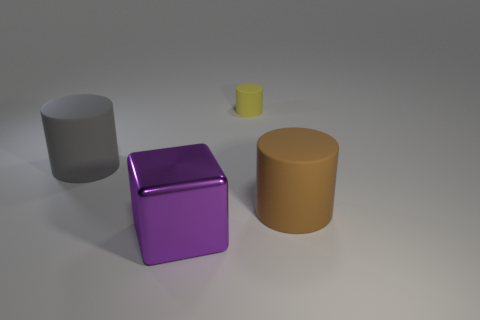How many other things are there of the same shape as the purple metallic thing?
Your answer should be compact. 0. There is a yellow matte object; is it the same shape as the purple metal object in front of the large brown matte cylinder?
Keep it short and to the point. No. There is a big thing that is in front of the big matte object to the right of the large purple metallic cube; what is it made of?
Your response must be concise. Metal. How many other rubber things have the same shape as the large brown thing?
Provide a short and direct response. 2. What shape is the big purple object?
Ensure brevity in your answer.  Cube. Is the number of tiny rubber objects less than the number of small brown metallic cubes?
Provide a short and direct response. No. Is there any other thing that is the same size as the metal thing?
Make the answer very short. Yes. There is another big object that is the same shape as the large brown matte thing; what material is it?
Provide a short and direct response. Rubber. Are there more big objects than yellow matte cylinders?
Give a very brief answer. Yes. What number of other things are there of the same color as the metallic cube?
Provide a short and direct response. 0. 